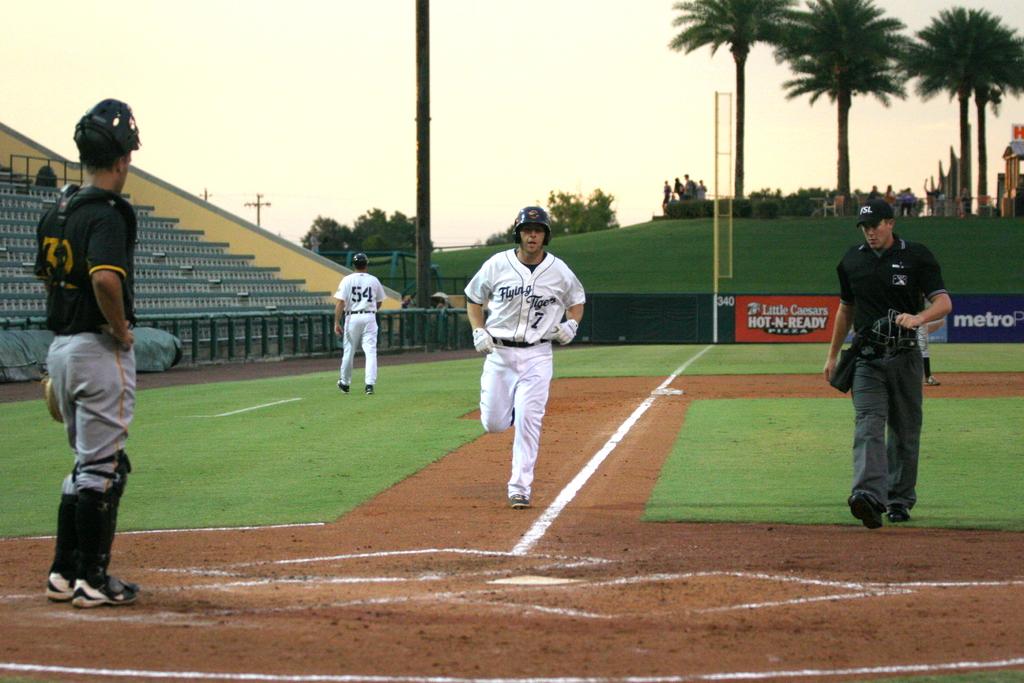What is the number of the player running to home plate?
Provide a short and direct response. 7. What team are the white uniforms?
Keep it short and to the point. Flying tigers. 